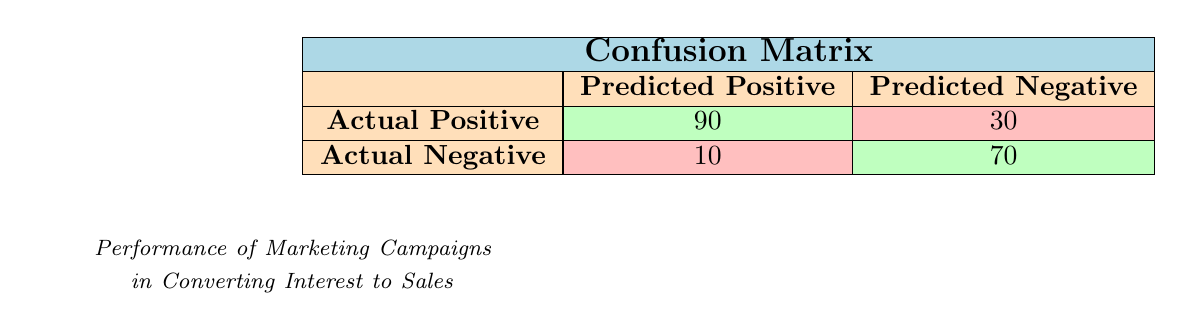What is the total number of True Positives? The table specifies that True Positives are represented by the value 90, which indicates the number of interested individuals who converted into sales.
Answer: 90 What is the total number of False Negatives? The table indicates that False Negatives amount to 30, representing the number of interested individuals who did not convert into sales.
Answer: 30 How many campaigns had a higher number of interested individuals than the Autumn Legends Retreat? The Autumn Legends Retreat has 100 interested individuals. The Spring Storytelling Festival (150), Summer Tales Adventure (200), and Local Folklore Experience (120) all exceed this number. Thus, there are three campaigns exceeding 100 interested individuals.
Answer: 3 What is the total number of converted individuals across all campaigns? To find this, we sum up the converted individuals from all campaigns: 90 (Spring) + 130 (Summer) + 40 (Autumn) + 50 (Winter) + 60 (Local) = 370.
Answer: 370 Is the number of True Negatives greater than False Positives? True Negatives are represented by the value 70, while False Positives are 10. Since 70 is greater than 10, the statement is true.
Answer: Yes What is the conversion rate for the Winter Stories Gala? The conversion rate can be calculated by taking the number of converted individuals (50) and dividing it by the number of interested individuals (80), resulting in a conversion rate of 50/80 = 0.625 or 62.5%.
Answer: 62.5% What is the total number of individuals targeted by the Autumn Legends Retreat campaign? The targeted number is the same as the number of interested individuals, which is 100.
Answer: 100 Which campaign had the lowest conversion rate, and what was that rate? The Autumn Legends Retreat had 40 converted from 100 interested, resulting in a conversion rate of 40/100 = 0.4 or 40%. This is the lowest among the campaigns.
Answer: Autumn Legends Retreat, 40% How many campaigns successfully converted more than 60 individuals? The campaigns that converted more than 60 individuals are the Spring Storytelling Festival (90), Summer Tales Adventure (130), and Winter Stories Gala (50, which does not count) resulting in two campaigns.
Answer: 2 If the number of True Positives increases by 10 and False Negatives decreases by 5, what will the new values be? If True Positives increase from 90 to 100 and False Negatives decrease from 30 to 25, these are the new values for TP and FN.
Answer: TP: 100, FN: 25 